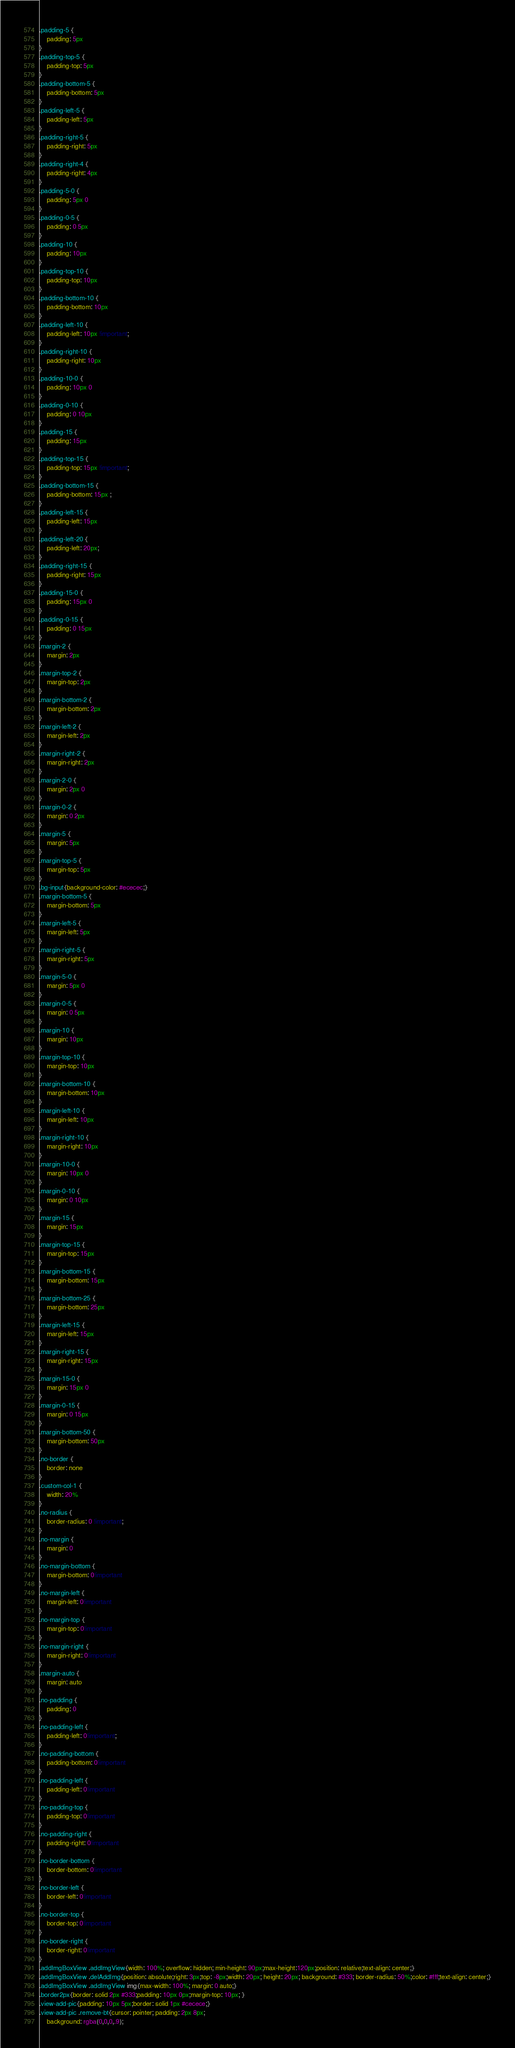Convert code to text. <code><loc_0><loc_0><loc_500><loc_500><_CSS_>.padding-5 {
    padding: 5px
}
.padding-top-5 {
    padding-top: 5px
}
.padding-bottom-5 {
    padding-bottom: 5px
}
.padding-left-5 {
    padding-left: 5px
}
.padding-right-5 {
    padding-right: 5px
}
.padding-right-4 {
    padding-right: 4px
}
.padding-5-0 {
    padding: 5px 0
}
.padding-0-5 {
    padding: 0 5px
}
.padding-10 {
    padding: 10px
}
.padding-top-10 {
    padding-top: 10px
}
.padding-bottom-10 {
    padding-bottom: 10px
}
.padding-left-10 {
    padding-left: 10px !important;
}
.padding-right-10 {
    padding-right: 10px
}
.padding-10-0 {
    padding: 10px 0
}
.padding-0-10 {
    padding: 0 10px
}
.padding-15 {
    padding: 15px
}
.padding-top-15 {
    padding-top: 15px !important;
}
.padding-bottom-15 {
    padding-bottom: 15px ;
}
.padding-left-15 {
    padding-left: 15px
}
.padding-left-20 {
    padding-left: 20px;
}
.padding-right-15 {
    padding-right: 15px
}
.padding-15-0 {
    padding: 15px 0
}
.padding-0-15 {
    padding: 0 15px
}
.margin-2 {
    margin: 2px
}
.margin-top-2 {
    margin-top: 2px
}
.margin-bottom-2 {
    margin-bottom: 2px
}
.margin-left-2 {
    margin-left: 2px
}
.margin-right-2 {
    margin-right: 2px
}
.margin-2-0 {
    margin: 2px 0
}
.margin-0-2 {
    margin: 0 2px
}
.margin-5 {
    margin: 5px
}
.margin-top-5 {
    margin-top: 5px
}
.bg-input{background-color: #ececec;}
.margin-bottom-5 {
    margin-bottom: 5px
}
.margin-left-5 {
    margin-left: 5px
}
.margin-right-5 {
    margin-right: 5px
}
.margin-5-0 {
    margin: 5px 0
}
.margin-0-5 {
    margin: 0 5px
}
.margin-10 {
    margin: 10px
}
.margin-top-10 {
    margin-top: 10px
}
.margin-bottom-10 {
    margin-bottom: 10px
}
.margin-left-10 {
    margin-left: 10px
}
.margin-right-10 {
    margin-right: 10px
}
.margin-10-0 {
    margin: 10px 0
}
.margin-0-10 {
    margin: 0 10px
}
.margin-15 {
    margin: 15px
}
.margin-top-15 {
    margin-top: 15px
}
.margin-bottom-15 {
    margin-bottom: 15px
}
.margin-bottom-25 {
    margin-bottom: 25px
}
.margin-left-15 {
    margin-left: 15px
}
.margin-right-15 {
    margin-right: 15px
}
.margin-15-0 {
    margin: 15px 0
}
.margin-0-15 {
    margin: 0 15px
}
.margin-bottom-50 {
    margin-bottom: 50px
}
.no-border {
    border: none
}
.custom-col-1 {
    width: 20%
}
.no-radius {
    border-radius: 0 !important;
}
.no-margin {
    margin: 0
}
.no-margin-bottom {
    margin-bottom: 0!important
}
.no-margin-left {
    margin-left: 0!important
}
.no-margin-top {
    margin-top: 0!important
}
.no-margin-right {
    margin-right: 0!important
}
.margin-auto {
    margin: auto
}
.no-padding {
    padding: 0
}
.no-padding-left {
    padding-left: 0!important;
}
.no-padding-bottom {
    padding-bottom: 0!important
}
.no-padding-left {
    padding-left: 0!important
}
.no-padding-top {
    padding-top: 0!important
}
.no-padding-right {
    padding-right: 0!important
}
.no-border-bottom {
    border-bottom: 0!important
}
.no-border-left {
    border-left: 0!important
}
.no-border-top {
    border-top: 0!important
}
.no-border-right {
    border-right: 0!important
}
.addImgBoxView .addImgView{width: 100%; overflow: hidden; min-height: 90px;max-height:120px;position: relative;text-align: center;}
.addImgBoxView .delAddImg{position: absolute;right: 3px;top: -8px;width: 20px; height: 20px; background: #333; border-radius: 50%;color: #fff;text-align: center;}
.addImgBoxView .addImgView img{max-width: 100%; margin: 0 auto;}
.border2px{border: solid 2px #333;padding: 10px 0px;margin-top: 10px; }
.view-add-pic{padding: 10px 5px;border: solid 1px #cecece;}
.view-add-pic .remove-bt{cursor: pointer; padding: 2px 8px;
    background: rgba(0,0,0,.9);</code> 